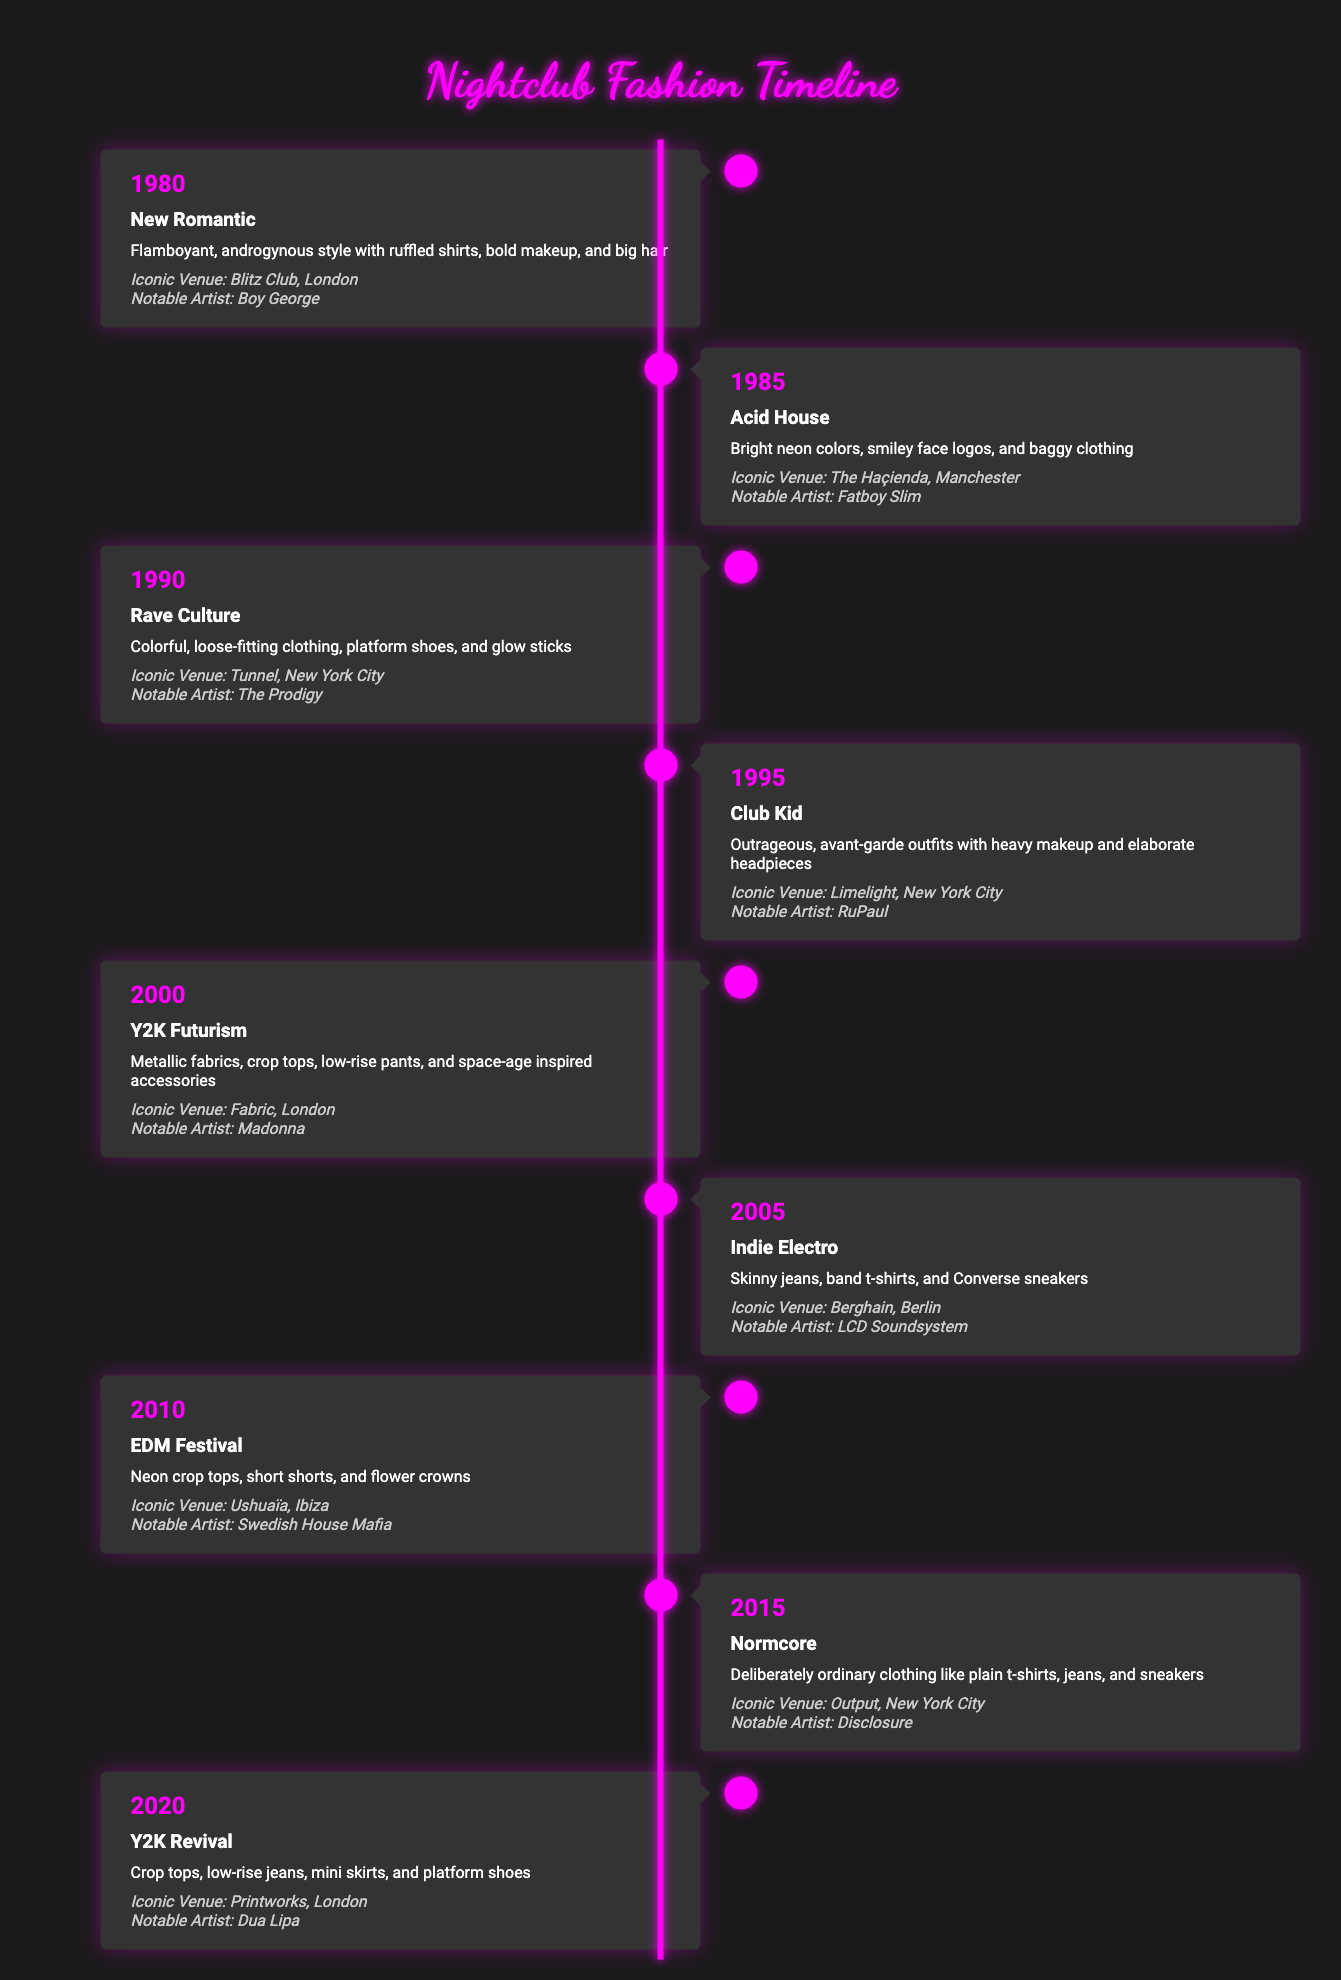What was the fashion trend in 1990? The table lists the trend for 1990 as "Rave Culture."
Answer: Rave Culture Which iconic venue is associated with the Acid House trend? The Acid House trend is associated with The Haçienda in Manchester as listed in the table.
Answer: The Haçienda, Manchester True or False: RuPaul was a notable artist in 1995. The table confirms that RuPaul is listed as the notable artist for the Club Kid trend in 1995, making this statement true.
Answer: True What are the two notable trends from the 2000s? The trends listed for the 2000s are "Y2K Futurism" in 2000 and "Indie Electro" in 2005.
Answer: Y2K Futurism and Indie Electro In which year did "New Romantic" fashion appear, and what was its description? "New Romantic" appeared in 1980, and it is described as "flamboyant, androgynous style with ruffled shirts, bold makeup, and big hair" according to the table.
Answer: 1980, flamboyant, androgynous style with ruffled shirts, bold makeup, and big hair What is the difference in years between Rave Culture and Y2K Futurism? Rave Culture was in 1990 and Y2K Futurism in 2000, so the difference is 2000 - 1990 = 10 years.
Answer: 10 years How many trends listed involve crop tops? The trends that involve crop tops are "Y2K Futurism" (2000), "EDM Festival" (2010), and "Y2K Revival" (2020). Thus, there are 3 trends with crop tops.
Answer: 3 What trend featured bright neon colors and when did it emerge? The trend that featured bright neon colors is "Acid House," which emerged in 1985 as per the table information.
Answer: Acid House, 1985 Is "Normcore" described as intentionally ordinary clothing? Yes, the table states that "Normcore" is described as "deliberately ordinary clothing like plain t-shirts, jeans, and sneakers," confirming this statement as true.
Answer: Yes 